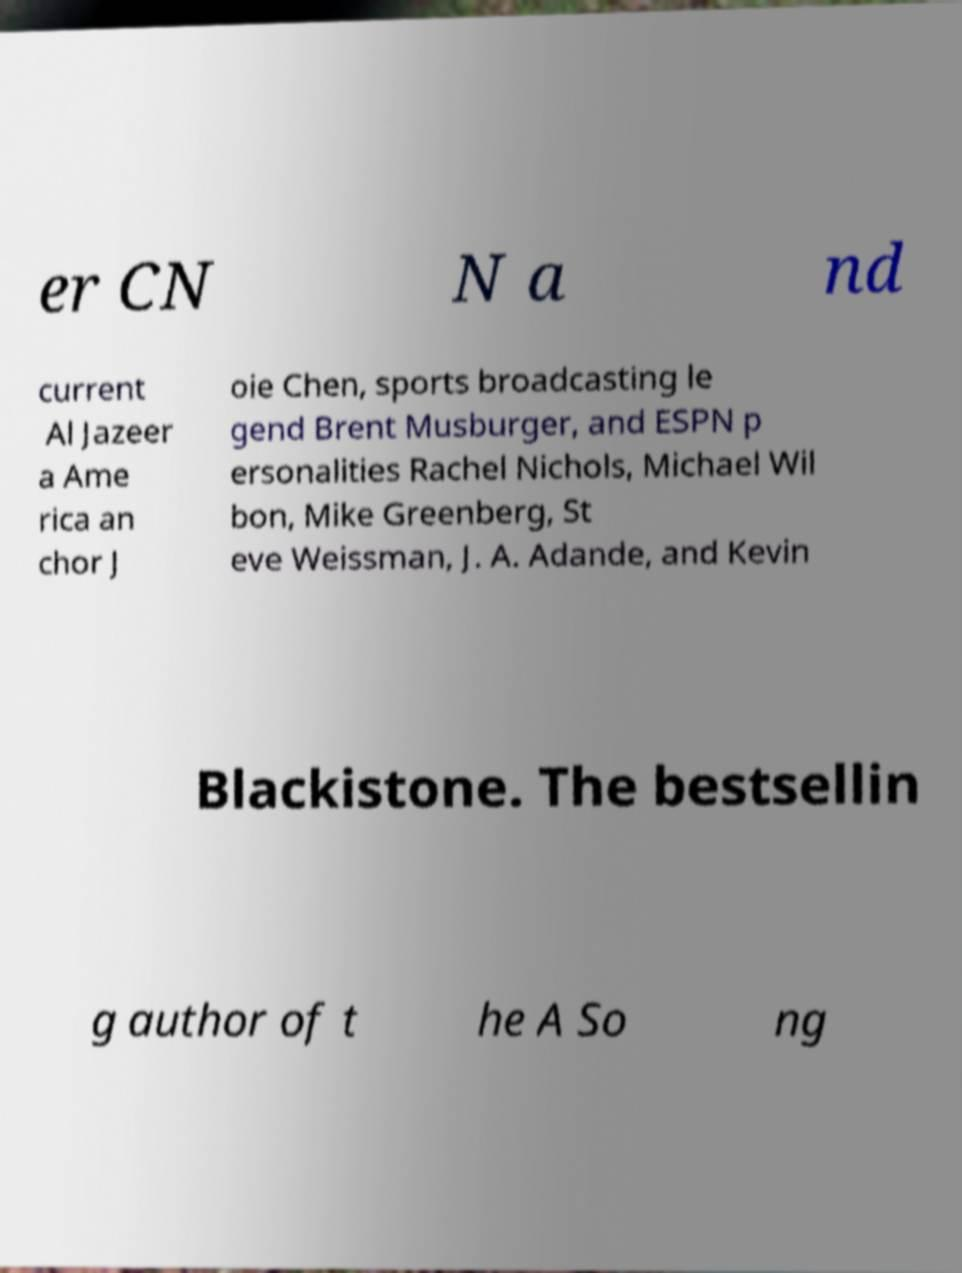Please read and relay the text visible in this image. What does it say? er CN N a nd current Al Jazeer a Ame rica an chor J oie Chen, sports broadcasting le gend Brent Musburger, and ESPN p ersonalities Rachel Nichols, Michael Wil bon, Mike Greenberg, St eve Weissman, J. A. Adande, and Kevin Blackistone. The bestsellin g author of t he A So ng 